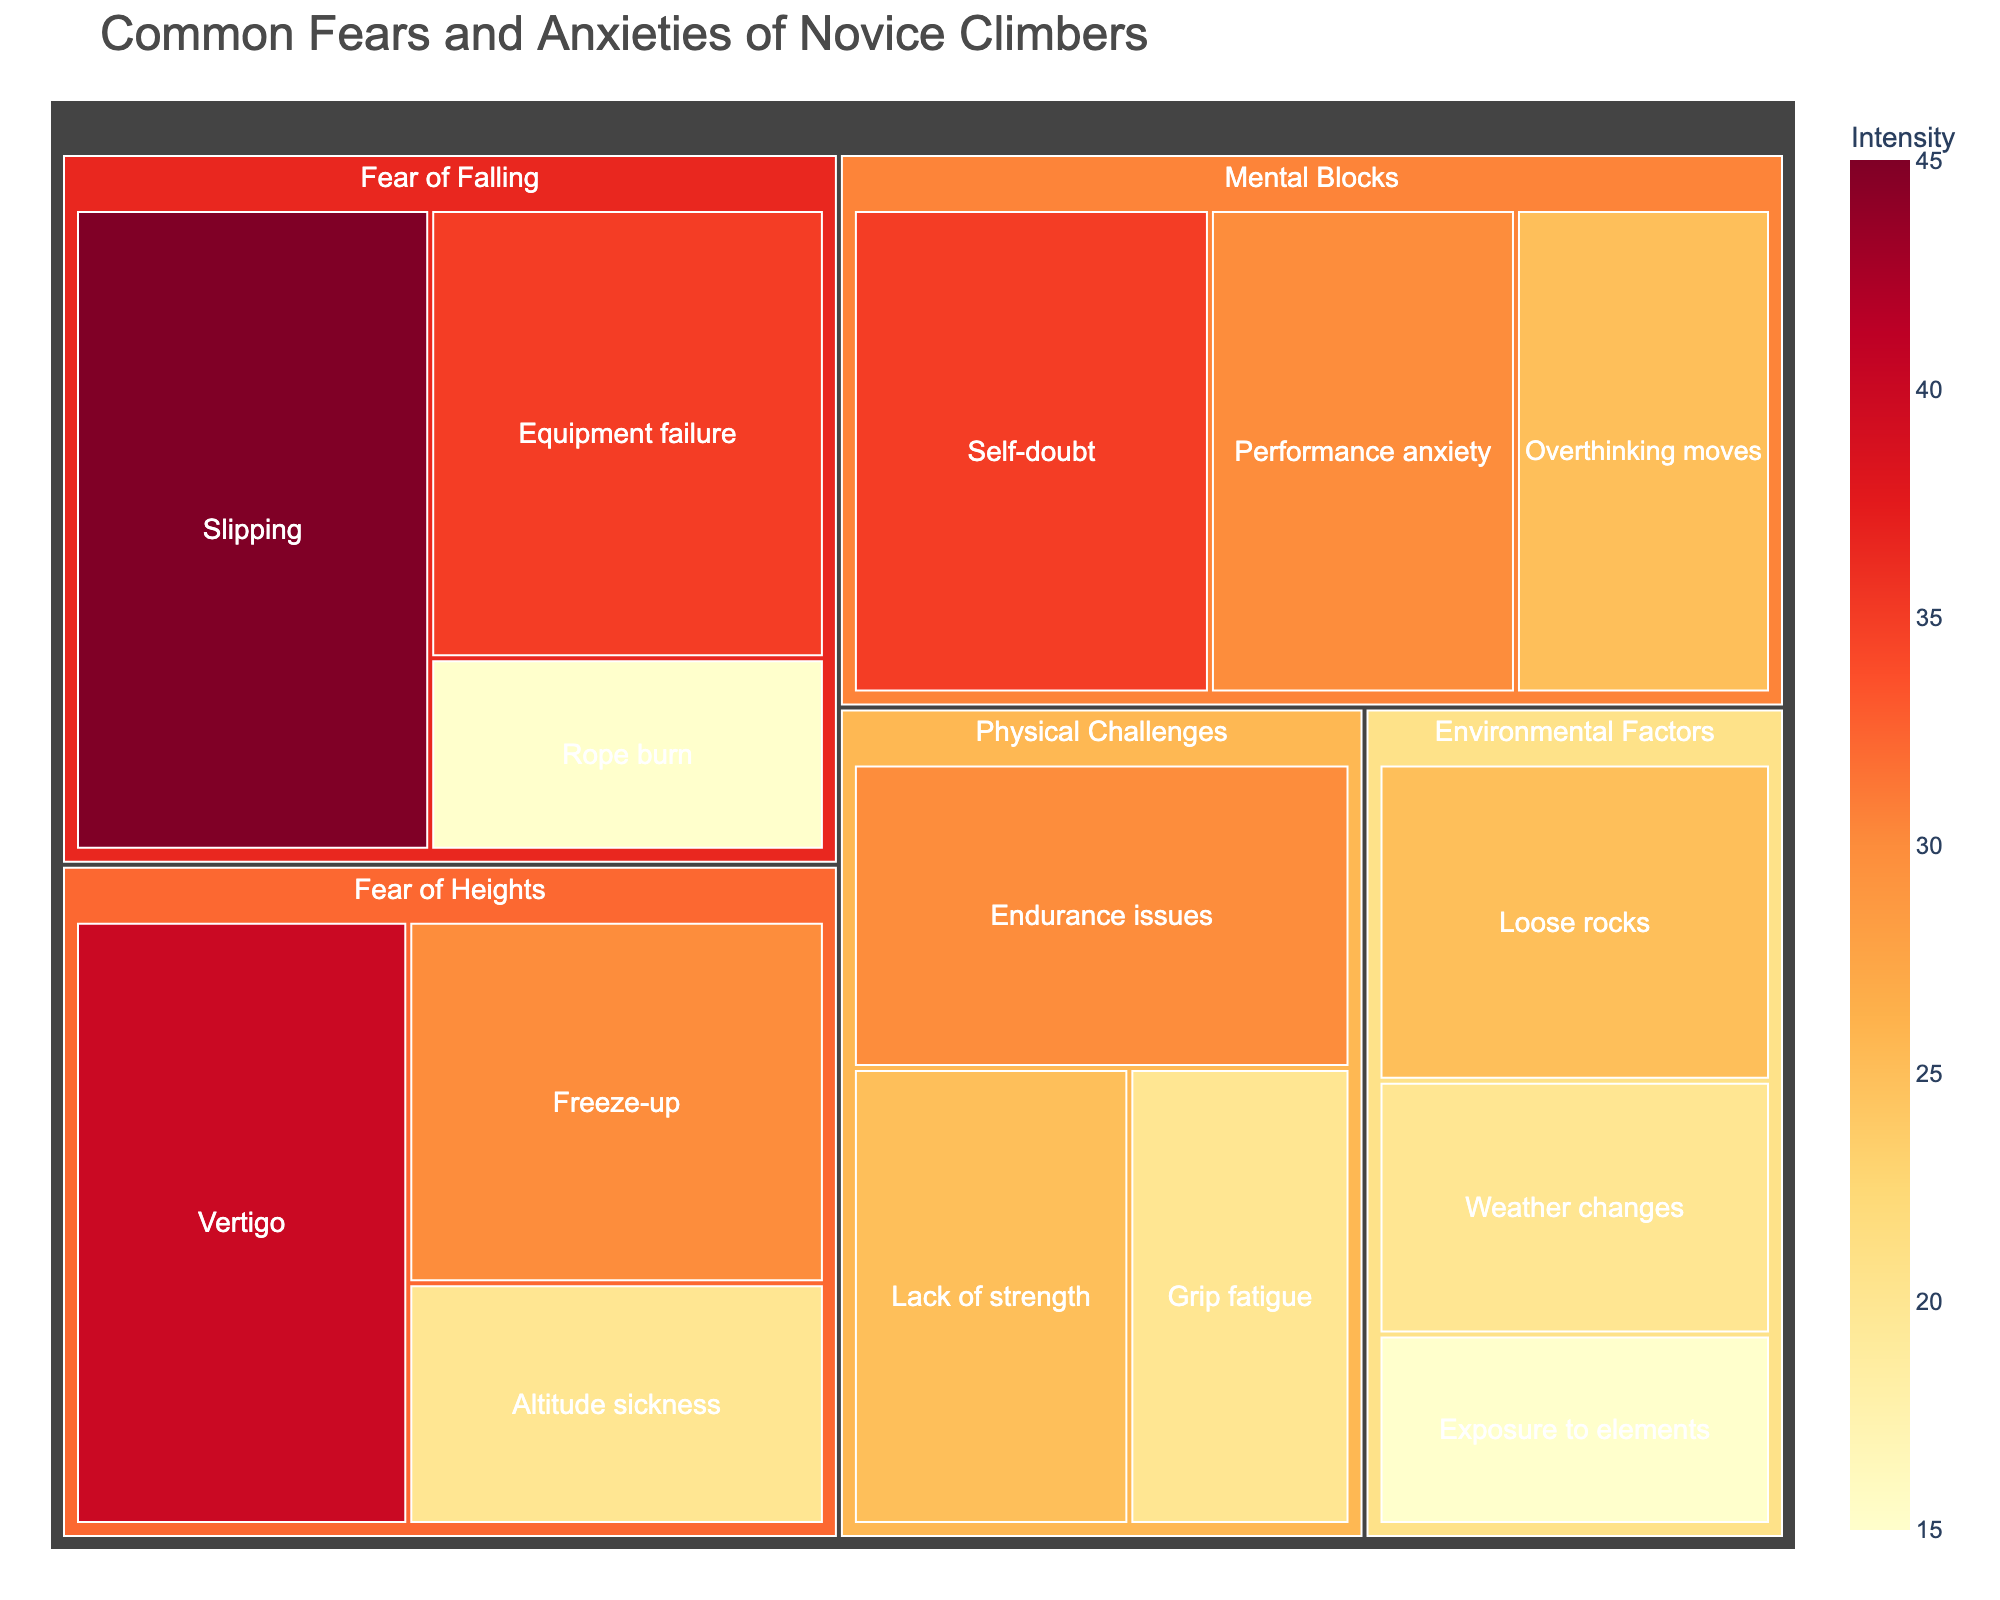How many subcategories are under the "Fear of Heights" category? The treemap shows three subcategories under the "Fear of Heights" category: Vertigo, Freeze-up, and Altitude sickness.
Answer: 3 What subcategory has the highest value under the "Mental Blocks" category? From the treemap, the "Self-doubt" subcategory under "Mental Blocks" has a value of 35, which is higher than the other subcategories in that category.
Answer: Self-doubt Which category has the highest total value? To find out which category has the highest total value, sum the values of each subcategory within all categories. The "Fear of Falling" category has subcategories with values (35+45+15), totaling 95, which is higher than any other category.
Answer: Fear of Falling Compare the values of the "Lack of strength" and "Endurance issues" subcategories. Which one is higher? The treemap shows the value of "Lack of strength" as 25 and "Endurance issues" as 30. "Endurance issues" has a higher value.
Answer: Endurance issues What is the total value for all subcategories under "Environmental Factors"? The values for "Environmental Factors" are Weather changes (20), Loose rocks (25), and Exposure to elements (15). Their total value is 20 + 25 + 15 = 60.
Answer: 60 